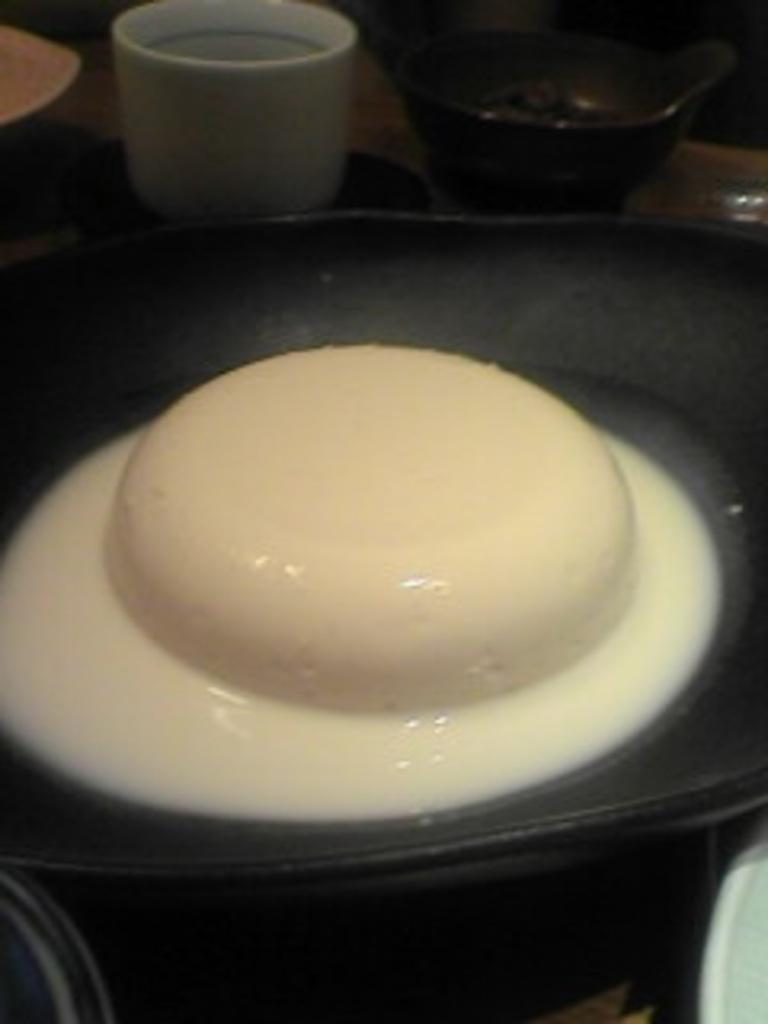What is on the plate in the image? There is a food item in a plate in the image. Where is the plate located? The plate is on a platform in the image. What can be seen in the background of the image? There are cups and other objects in the background of the image. What time of day is it in the image, and is the mother present? The time of day and the presence of a mother cannot be determined from the image, as there is no information provided about these aspects. 